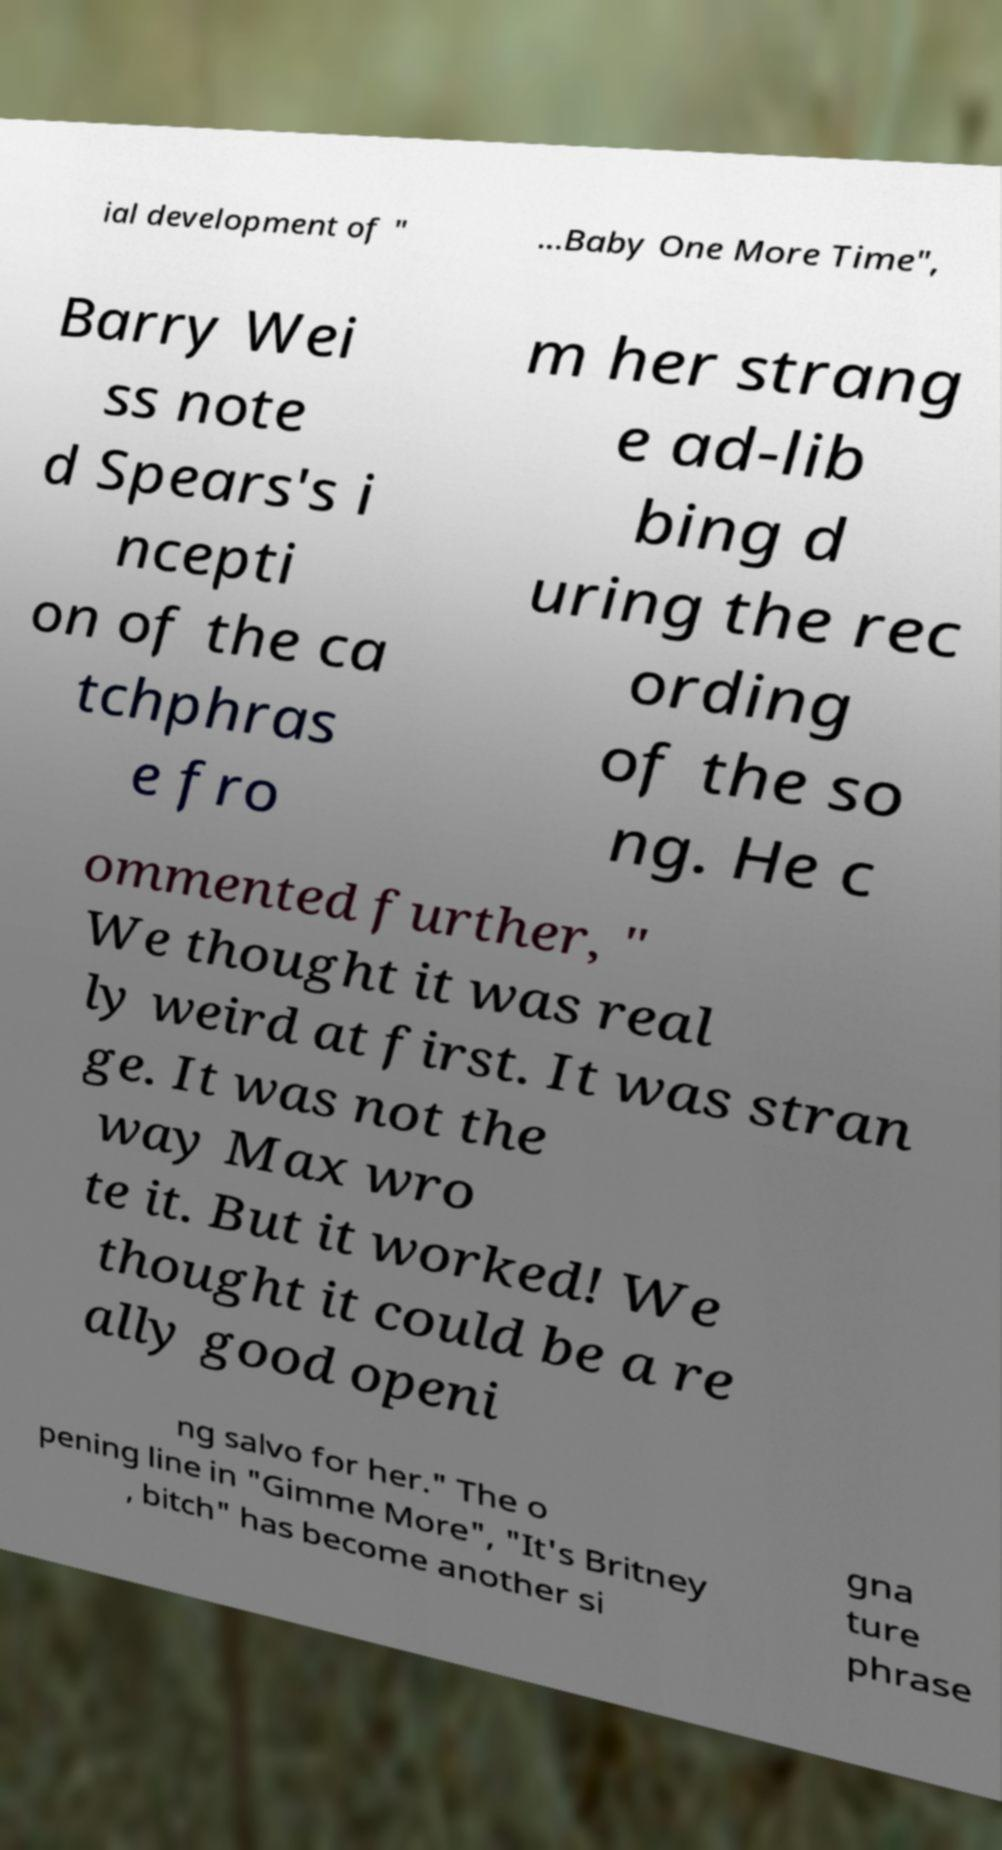I need the written content from this picture converted into text. Can you do that? ial development of " ...Baby One More Time", Barry Wei ss note d Spears's i ncepti on of the ca tchphras e fro m her strang e ad-lib bing d uring the rec ording of the so ng. He c ommented further, " We thought it was real ly weird at first. It was stran ge. It was not the way Max wro te it. But it worked! We thought it could be a re ally good openi ng salvo for her." The o pening line in "Gimme More", "It's Britney , bitch" has become another si gna ture phrase 